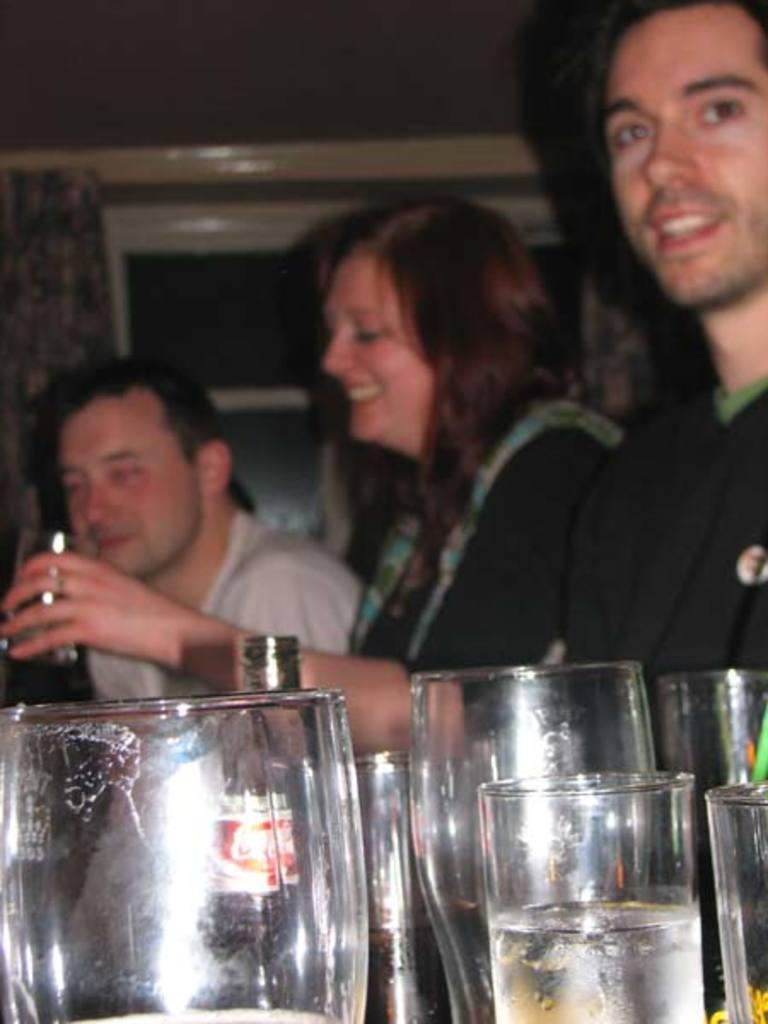What objects are in the foreground of the image? There are glasses and bottles in the foreground of the image. What can be seen in the background of the image? There are persons and a wall in the background of the image. How many types of objects are present in the foreground? There are two types of objects in the foreground: glasses and bottles. What is the setting of the background? The background features a wall and people, which suggests an indoor or outdoor setting. What type of garden can be seen in the image? There is no garden present in the image; it features glasses, bottles, persons, and a wall. 